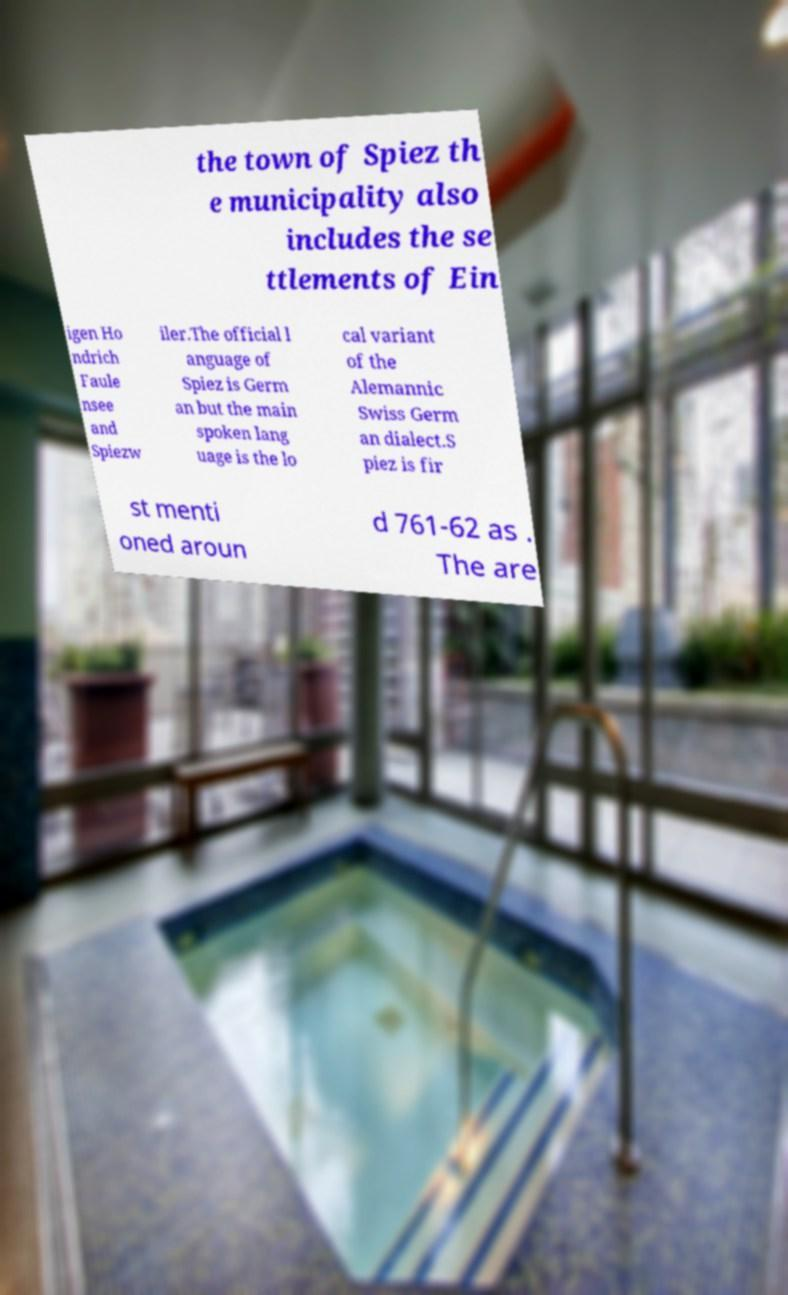Could you extract and type out the text from this image? the town of Spiez th e municipality also includes the se ttlements of Ein igen Ho ndrich Faule nsee and Spiezw iler.The official l anguage of Spiez is Germ an but the main spoken lang uage is the lo cal variant of the Alemannic Swiss Germ an dialect.S piez is fir st menti oned aroun d 761-62 as . The are 